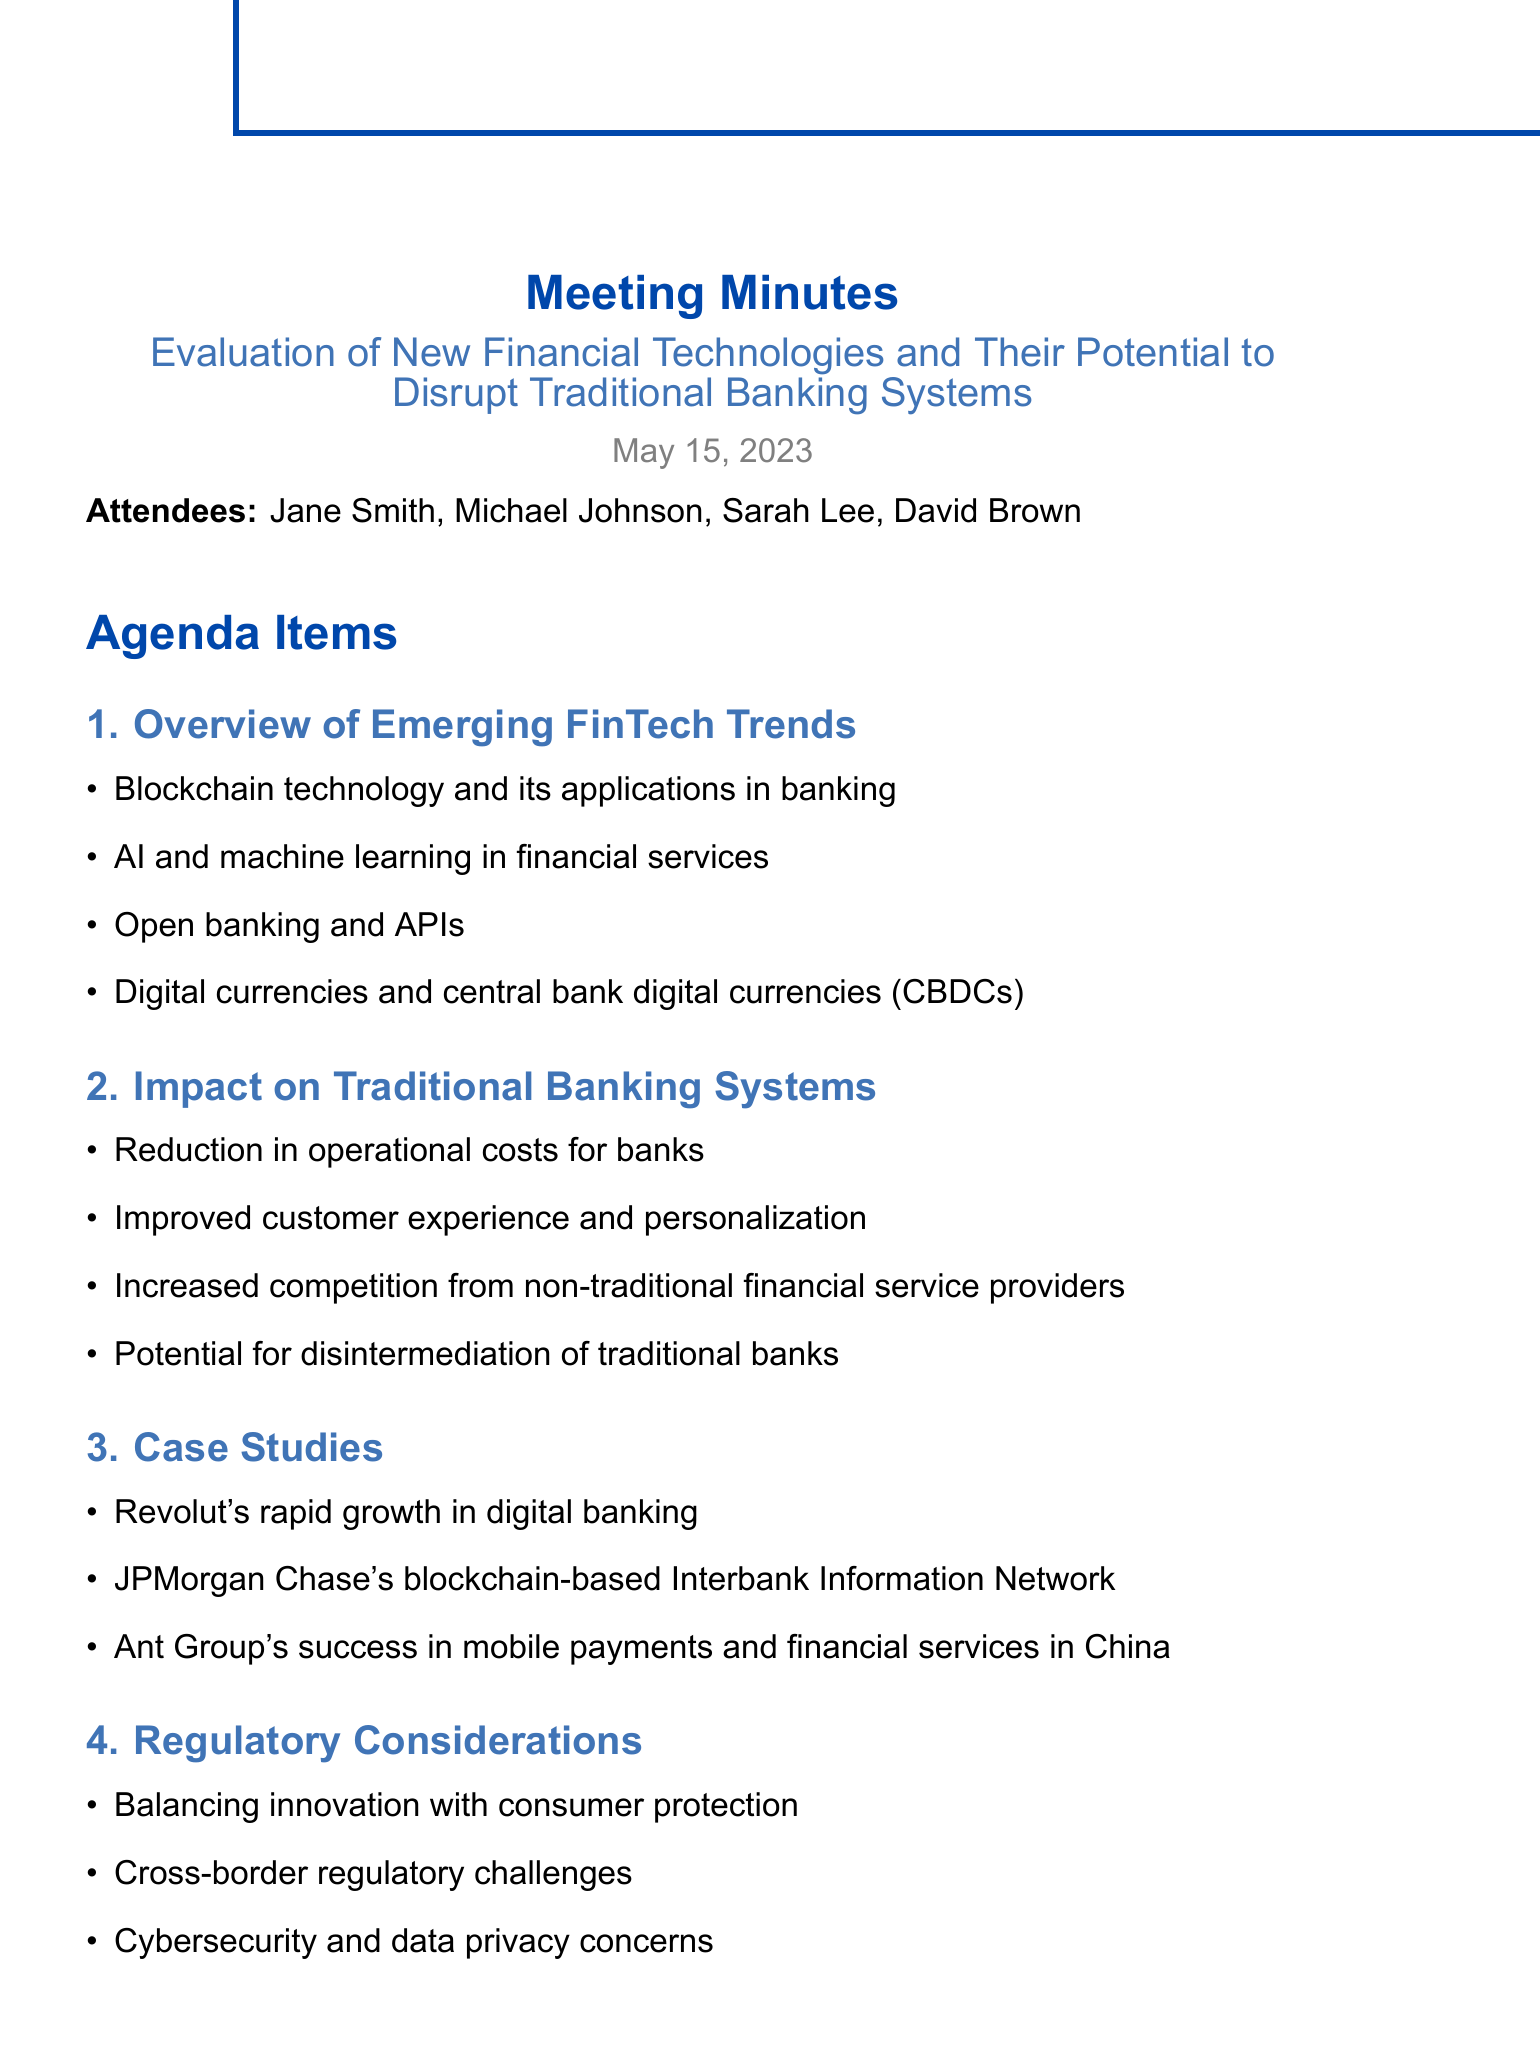What is the date of the meeting? The date of the meeting is explicitly mentioned in the document as May 15, 2023.
Answer: May 15, 2023 Who is the Chief Editor? The document lists Jane Smith as the Chief Editor among the attendees.
Answer: Jane Smith What financial technology is associated with reducing operational costs for banks? The key point regarding the impact of traditional banking systems mentions a reduction in operational costs, linked to advancements in financial technologies.
Answer: FinTech What is one of the case studies mentioned in the meeting? A specific example is provided under case studies, such as Revolut's rapid growth.
Answer: Revolut's rapid growth in digital banking What regulatory consideration is highlighted in the document? Regulation is a key area discussed, and balancing innovation with consumer protection is one of the primary considerations noted.
Answer: Balancing innovation with consumer protection How many attendees were present at the meeting? The document lists four individuals as attendees, which is the total count mentioned.
Answer: Four What is one prediction about the future outlook? The future outlook includes predictions on the evolution of banking business models, which indicates anticipated changes in banking practices.
Answer: Evolution of banking business models to incorporate new technologies What will be analyzed according to the action items? The action items outline that there will be an analysis of recent regulatory developments, specifying a focus area for future work.
Answer: Recent regulatory developments in major financial markets 